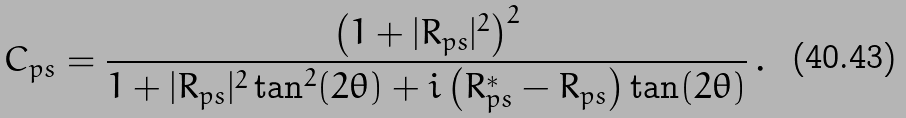Convert formula to latex. <formula><loc_0><loc_0><loc_500><loc_500>C _ { p s } = \frac { \left ( 1 + | R _ { p s } | ^ { 2 } \right ) ^ { 2 } } { 1 + | R _ { p s } | ^ { 2 } \tan ^ { 2 } ( 2 \theta ) + i \left ( R _ { p s } ^ { * } - R _ { p s } \right ) \tan ( 2 \theta ) } \, .</formula> 